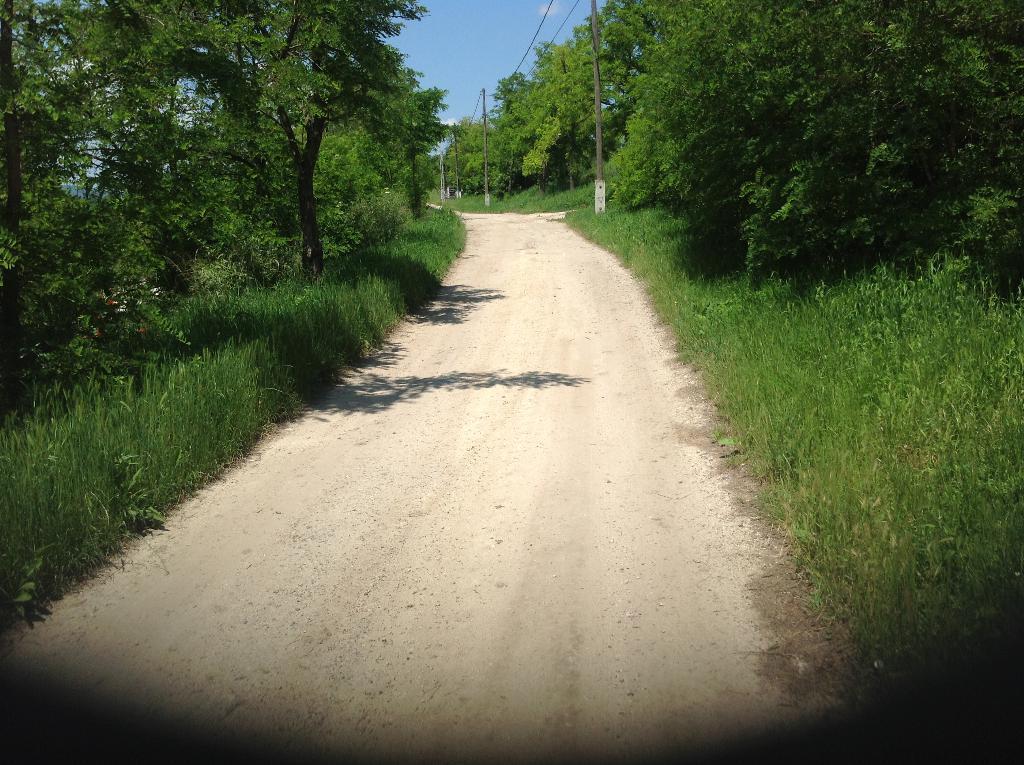Could you give a brief overview of what you see in this image? In this picture, we can see the path, ground with grass, plants, trees, poles, wires and the sky with clouds. 